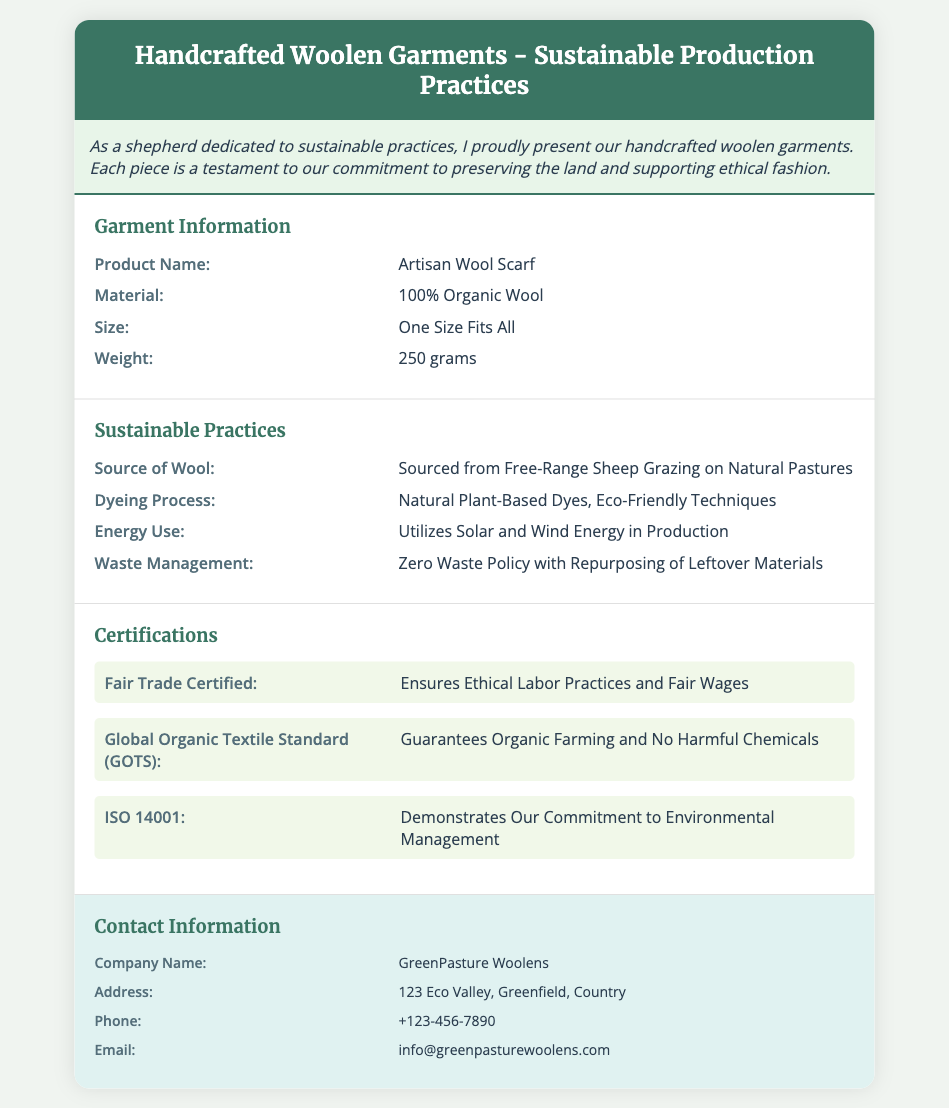What is the product name? The product name is listed under the Garment Information section.
Answer: Artisan Wool Scarf What material is used for the garment? The material is specified in the Garment Information section.
Answer: 100% Organic Wool What is the size of the garment? The size is provided in the Garment Information section.
Answer: One Size Fits All What energy sources are used in production? The energy sources used are mentioned in the Sustainable Practices section.
Answer: Solar and Wind Energy What waste management policy is practiced? The waste management policy is described in the Sustainable Practices section.
Answer: Zero Waste Policy Which certification ensures fair labor practices? The certification ensuring fair labor practices is noted in the Certifications section.
Answer: Fair Trade Certified What does GOTS guarantee? The guarantee provided by GOTS is detailed in the Certifications section.
Answer: Organic Farming and No Harmful Chemicals What is the weight of the garment? The weight is specified in the Garment Information section.
Answer: 250 grams What is the company name? The company name is mentioned in the Contact Information section.
Answer: GreenPasture Woolens 